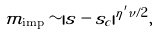<formula> <loc_0><loc_0><loc_500><loc_500>m _ { \text {imp} } \sim | s - s _ { c } | ^ { \eta ^ { \prime } \nu / 2 } ,</formula> 